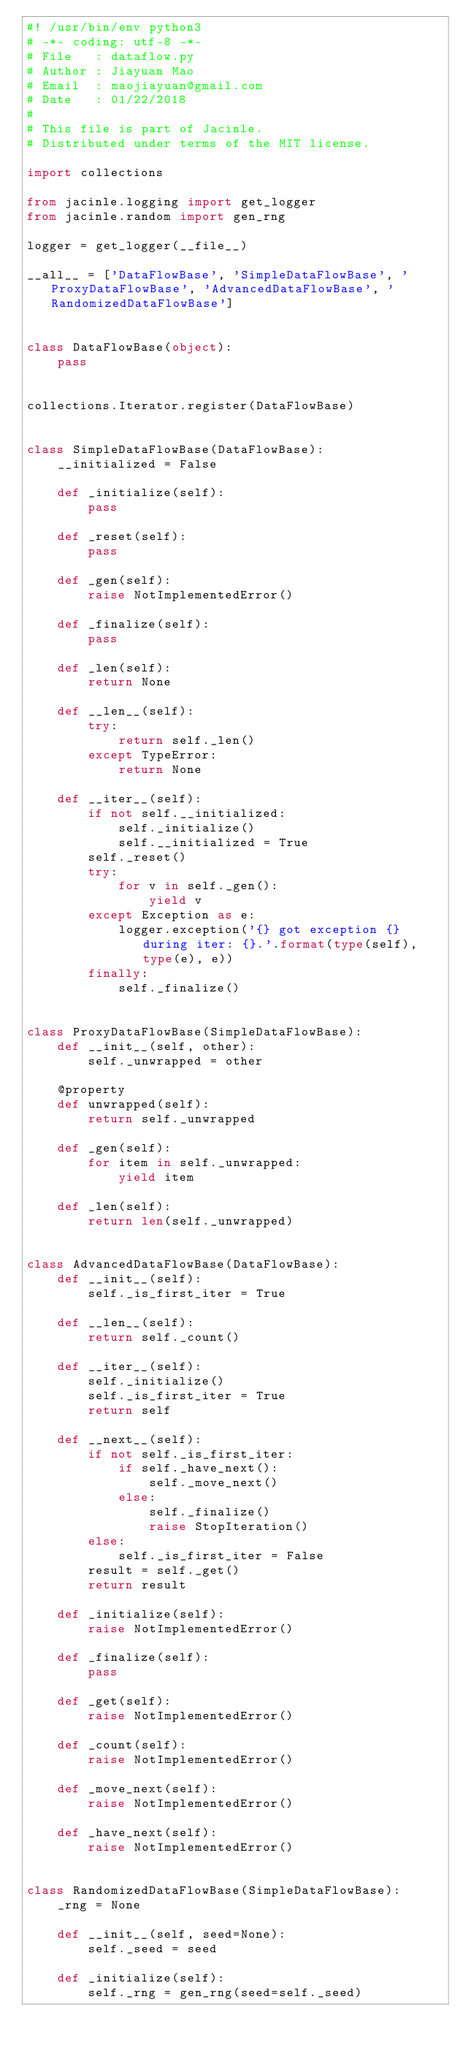Convert code to text. <code><loc_0><loc_0><loc_500><loc_500><_Python_>#! /usr/bin/env python3
# -*- coding: utf-8 -*-
# File   : dataflow.py
# Author : Jiayuan Mao
# Email  : maojiayuan@gmail.com
# Date   : 01/22/2018
#
# This file is part of Jacinle.
# Distributed under terms of the MIT license.

import collections

from jacinle.logging import get_logger
from jacinle.random import gen_rng

logger = get_logger(__file__)

__all__ = ['DataFlowBase', 'SimpleDataFlowBase', 'ProxyDataFlowBase', 'AdvancedDataFlowBase', 'RandomizedDataFlowBase']


class DataFlowBase(object):
    pass


collections.Iterator.register(DataFlowBase)


class SimpleDataFlowBase(DataFlowBase):
    __initialized = False

    def _initialize(self):
        pass

    def _reset(self):
        pass

    def _gen(self):
        raise NotImplementedError()

    def _finalize(self):
        pass

    def _len(self):
        return None

    def __len__(self):
        try:
            return self._len()
        except TypeError:
            return None

    def __iter__(self):
        if not self.__initialized:
            self._initialize()
            self.__initialized = True
        self._reset()
        try:
            for v in self._gen():
                yield v
        except Exception as e:
            logger.exception('{} got exception {} during iter: {}.'.format(type(self), type(e), e))
        finally:
            self._finalize()


class ProxyDataFlowBase(SimpleDataFlowBase):
    def __init__(self, other):
        self._unwrapped = other

    @property
    def unwrapped(self):
        return self._unwrapped

    def _gen(self):
        for item in self._unwrapped:
            yield item

    def _len(self):
        return len(self._unwrapped)


class AdvancedDataFlowBase(DataFlowBase):
    def __init__(self):
        self._is_first_iter = True

    def __len__(self):
        return self._count()

    def __iter__(self):
        self._initialize()
        self._is_first_iter = True
        return self

    def __next__(self):
        if not self._is_first_iter:
            if self._have_next():
                self._move_next()
            else:
                self._finalize()
                raise StopIteration()
        else:
            self._is_first_iter = False
        result = self._get()
        return result

    def _initialize(self):
        raise NotImplementedError()

    def _finalize(self):
        pass

    def _get(self):
        raise NotImplementedError()

    def _count(self):
        raise NotImplementedError()

    def _move_next(self):
        raise NotImplementedError()

    def _have_next(self):
        raise NotImplementedError()


class RandomizedDataFlowBase(SimpleDataFlowBase):
    _rng = None

    def __init__(self, seed=None):
        self._seed = seed

    def _initialize(self):
        self._rng = gen_rng(seed=self._seed)
</code> 